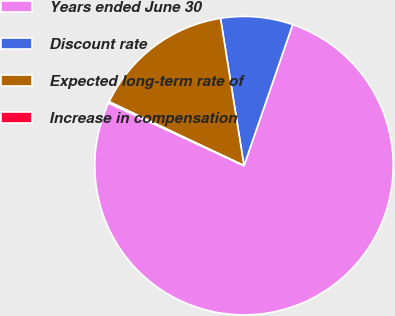<chart> <loc_0><loc_0><loc_500><loc_500><pie_chart><fcel>Years ended June 30<fcel>Discount rate<fcel>Expected long-term rate of<fcel>Increase in compensation<nl><fcel>76.61%<fcel>7.8%<fcel>15.44%<fcel>0.15%<nl></chart> 